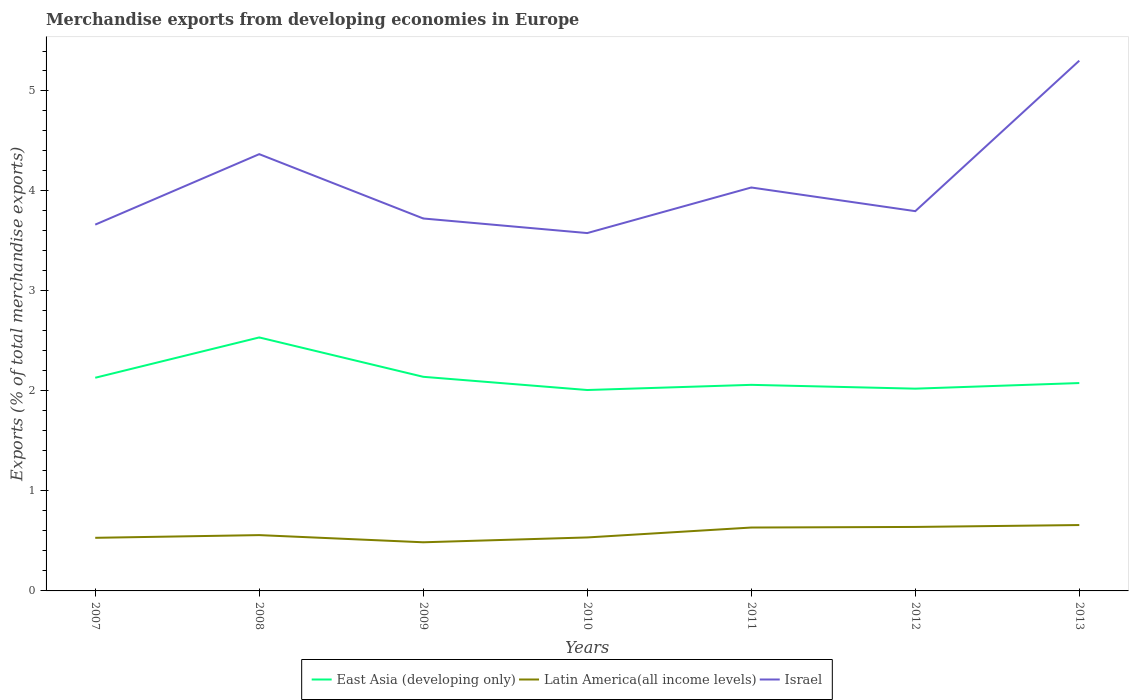Is the number of lines equal to the number of legend labels?
Provide a short and direct response. Yes. Across all years, what is the maximum percentage of total merchandise exports in Latin America(all income levels)?
Make the answer very short. 0.49. What is the total percentage of total merchandise exports in East Asia (developing only) in the graph?
Give a very brief answer. 0.53. What is the difference between the highest and the second highest percentage of total merchandise exports in East Asia (developing only)?
Offer a terse response. 0.53. What is the difference between the highest and the lowest percentage of total merchandise exports in East Asia (developing only)?
Give a very brief answer. 2. Is the percentage of total merchandise exports in East Asia (developing only) strictly greater than the percentage of total merchandise exports in Israel over the years?
Offer a terse response. Yes. What is the difference between two consecutive major ticks on the Y-axis?
Provide a succinct answer. 1. Does the graph contain any zero values?
Offer a very short reply. No. How are the legend labels stacked?
Give a very brief answer. Horizontal. What is the title of the graph?
Keep it short and to the point. Merchandise exports from developing economies in Europe. Does "Iraq" appear as one of the legend labels in the graph?
Offer a very short reply. No. What is the label or title of the Y-axis?
Offer a very short reply. Exports (% of total merchandise exports). What is the Exports (% of total merchandise exports) in East Asia (developing only) in 2007?
Offer a very short reply. 2.13. What is the Exports (% of total merchandise exports) in Latin America(all income levels) in 2007?
Keep it short and to the point. 0.53. What is the Exports (% of total merchandise exports) in Israel in 2007?
Offer a terse response. 3.66. What is the Exports (% of total merchandise exports) of East Asia (developing only) in 2008?
Offer a terse response. 2.54. What is the Exports (% of total merchandise exports) in Latin America(all income levels) in 2008?
Provide a succinct answer. 0.56. What is the Exports (% of total merchandise exports) in Israel in 2008?
Your answer should be very brief. 4.37. What is the Exports (% of total merchandise exports) in East Asia (developing only) in 2009?
Your answer should be very brief. 2.14. What is the Exports (% of total merchandise exports) in Latin America(all income levels) in 2009?
Provide a short and direct response. 0.49. What is the Exports (% of total merchandise exports) in Israel in 2009?
Your response must be concise. 3.72. What is the Exports (% of total merchandise exports) in East Asia (developing only) in 2010?
Offer a terse response. 2.01. What is the Exports (% of total merchandise exports) of Latin America(all income levels) in 2010?
Make the answer very short. 0.53. What is the Exports (% of total merchandise exports) in Israel in 2010?
Keep it short and to the point. 3.58. What is the Exports (% of total merchandise exports) of East Asia (developing only) in 2011?
Provide a succinct answer. 2.06. What is the Exports (% of total merchandise exports) of Latin America(all income levels) in 2011?
Offer a terse response. 0.63. What is the Exports (% of total merchandise exports) of Israel in 2011?
Give a very brief answer. 4.03. What is the Exports (% of total merchandise exports) of East Asia (developing only) in 2012?
Your answer should be compact. 2.02. What is the Exports (% of total merchandise exports) of Latin America(all income levels) in 2012?
Provide a succinct answer. 0.64. What is the Exports (% of total merchandise exports) of Israel in 2012?
Your answer should be compact. 3.8. What is the Exports (% of total merchandise exports) of East Asia (developing only) in 2013?
Offer a terse response. 2.08. What is the Exports (% of total merchandise exports) of Latin America(all income levels) in 2013?
Give a very brief answer. 0.66. What is the Exports (% of total merchandise exports) of Israel in 2013?
Keep it short and to the point. 5.3. Across all years, what is the maximum Exports (% of total merchandise exports) of East Asia (developing only)?
Your answer should be very brief. 2.54. Across all years, what is the maximum Exports (% of total merchandise exports) of Latin America(all income levels)?
Your answer should be very brief. 0.66. Across all years, what is the maximum Exports (% of total merchandise exports) of Israel?
Your answer should be very brief. 5.3. Across all years, what is the minimum Exports (% of total merchandise exports) in East Asia (developing only)?
Make the answer very short. 2.01. Across all years, what is the minimum Exports (% of total merchandise exports) of Latin America(all income levels)?
Provide a short and direct response. 0.49. Across all years, what is the minimum Exports (% of total merchandise exports) in Israel?
Your answer should be compact. 3.58. What is the total Exports (% of total merchandise exports) in East Asia (developing only) in the graph?
Offer a very short reply. 14.98. What is the total Exports (% of total merchandise exports) of Latin America(all income levels) in the graph?
Give a very brief answer. 4.04. What is the total Exports (% of total merchandise exports) of Israel in the graph?
Offer a terse response. 28.47. What is the difference between the Exports (% of total merchandise exports) in East Asia (developing only) in 2007 and that in 2008?
Your response must be concise. -0.4. What is the difference between the Exports (% of total merchandise exports) in Latin America(all income levels) in 2007 and that in 2008?
Offer a very short reply. -0.03. What is the difference between the Exports (% of total merchandise exports) in Israel in 2007 and that in 2008?
Make the answer very short. -0.7. What is the difference between the Exports (% of total merchandise exports) of East Asia (developing only) in 2007 and that in 2009?
Give a very brief answer. -0.01. What is the difference between the Exports (% of total merchandise exports) of Latin America(all income levels) in 2007 and that in 2009?
Give a very brief answer. 0.04. What is the difference between the Exports (% of total merchandise exports) of Israel in 2007 and that in 2009?
Offer a terse response. -0.06. What is the difference between the Exports (% of total merchandise exports) in East Asia (developing only) in 2007 and that in 2010?
Your answer should be very brief. 0.12. What is the difference between the Exports (% of total merchandise exports) of Latin America(all income levels) in 2007 and that in 2010?
Offer a very short reply. -0. What is the difference between the Exports (% of total merchandise exports) in Israel in 2007 and that in 2010?
Keep it short and to the point. 0.08. What is the difference between the Exports (% of total merchandise exports) of East Asia (developing only) in 2007 and that in 2011?
Your response must be concise. 0.07. What is the difference between the Exports (% of total merchandise exports) in Latin America(all income levels) in 2007 and that in 2011?
Your answer should be very brief. -0.1. What is the difference between the Exports (% of total merchandise exports) of Israel in 2007 and that in 2011?
Give a very brief answer. -0.37. What is the difference between the Exports (% of total merchandise exports) in East Asia (developing only) in 2007 and that in 2012?
Make the answer very short. 0.11. What is the difference between the Exports (% of total merchandise exports) in Latin America(all income levels) in 2007 and that in 2012?
Ensure brevity in your answer.  -0.11. What is the difference between the Exports (% of total merchandise exports) of Israel in 2007 and that in 2012?
Offer a very short reply. -0.13. What is the difference between the Exports (% of total merchandise exports) in East Asia (developing only) in 2007 and that in 2013?
Make the answer very short. 0.05. What is the difference between the Exports (% of total merchandise exports) in Latin America(all income levels) in 2007 and that in 2013?
Your answer should be compact. -0.13. What is the difference between the Exports (% of total merchandise exports) of Israel in 2007 and that in 2013?
Your response must be concise. -1.64. What is the difference between the Exports (% of total merchandise exports) of East Asia (developing only) in 2008 and that in 2009?
Offer a terse response. 0.39. What is the difference between the Exports (% of total merchandise exports) in Latin America(all income levels) in 2008 and that in 2009?
Provide a short and direct response. 0.07. What is the difference between the Exports (% of total merchandise exports) in Israel in 2008 and that in 2009?
Give a very brief answer. 0.64. What is the difference between the Exports (% of total merchandise exports) in East Asia (developing only) in 2008 and that in 2010?
Your answer should be very brief. 0.53. What is the difference between the Exports (% of total merchandise exports) of Latin America(all income levels) in 2008 and that in 2010?
Your answer should be very brief. 0.02. What is the difference between the Exports (% of total merchandise exports) of Israel in 2008 and that in 2010?
Ensure brevity in your answer.  0.79. What is the difference between the Exports (% of total merchandise exports) in East Asia (developing only) in 2008 and that in 2011?
Make the answer very short. 0.47. What is the difference between the Exports (% of total merchandise exports) in Latin America(all income levels) in 2008 and that in 2011?
Offer a terse response. -0.08. What is the difference between the Exports (% of total merchandise exports) of Israel in 2008 and that in 2011?
Your answer should be compact. 0.33. What is the difference between the Exports (% of total merchandise exports) of East Asia (developing only) in 2008 and that in 2012?
Keep it short and to the point. 0.51. What is the difference between the Exports (% of total merchandise exports) in Latin America(all income levels) in 2008 and that in 2012?
Offer a terse response. -0.08. What is the difference between the Exports (% of total merchandise exports) in Israel in 2008 and that in 2012?
Make the answer very short. 0.57. What is the difference between the Exports (% of total merchandise exports) of East Asia (developing only) in 2008 and that in 2013?
Your answer should be very brief. 0.46. What is the difference between the Exports (% of total merchandise exports) in Latin America(all income levels) in 2008 and that in 2013?
Your answer should be compact. -0.1. What is the difference between the Exports (% of total merchandise exports) in Israel in 2008 and that in 2013?
Keep it short and to the point. -0.94. What is the difference between the Exports (% of total merchandise exports) in East Asia (developing only) in 2009 and that in 2010?
Offer a terse response. 0.13. What is the difference between the Exports (% of total merchandise exports) of Latin America(all income levels) in 2009 and that in 2010?
Provide a succinct answer. -0.05. What is the difference between the Exports (% of total merchandise exports) in Israel in 2009 and that in 2010?
Offer a very short reply. 0.15. What is the difference between the Exports (% of total merchandise exports) of East Asia (developing only) in 2009 and that in 2011?
Provide a succinct answer. 0.08. What is the difference between the Exports (% of total merchandise exports) in Latin America(all income levels) in 2009 and that in 2011?
Your answer should be very brief. -0.15. What is the difference between the Exports (% of total merchandise exports) of Israel in 2009 and that in 2011?
Your answer should be compact. -0.31. What is the difference between the Exports (% of total merchandise exports) in East Asia (developing only) in 2009 and that in 2012?
Provide a succinct answer. 0.12. What is the difference between the Exports (% of total merchandise exports) in Latin America(all income levels) in 2009 and that in 2012?
Your response must be concise. -0.15. What is the difference between the Exports (% of total merchandise exports) in Israel in 2009 and that in 2012?
Your answer should be very brief. -0.07. What is the difference between the Exports (% of total merchandise exports) in East Asia (developing only) in 2009 and that in 2013?
Offer a terse response. 0.06. What is the difference between the Exports (% of total merchandise exports) of Latin America(all income levels) in 2009 and that in 2013?
Offer a terse response. -0.17. What is the difference between the Exports (% of total merchandise exports) of Israel in 2009 and that in 2013?
Your response must be concise. -1.58. What is the difference between the Exports (% of total merchandise exports) in East Asia (developing only) in 2010 and that in 2011?
Provide a short and direct response. -0.05. What is the difference between the Exports (% of total merchandise exports) of Latin America(all income levels) in 2010 and that in 2011?
Provide a succinct answer. -0.1. What is the difference between the Exports (% of total merchandise exports) in Israel in 2010 and that in 2011?
Your answer should be compact. -0.46. What is the difference between the Exports (% of total merchandise exports) of East Asia (developing only) in 2010 and that in 2012?
Keep it short and to the point. -0.01. What is the difference between the Exports (% of total merchandise exports) of Latin America(all income levels) in 2010 and that in 2012?
Offer a terse response. -0.1. What is the difference between the Exports (% of total merchandise exports) of Israel in 2010 and that in 2012?
Provide a short and direct response. -0.22. What is the difference between the Exports (% of total merchandise exports) in East Asia (developing only) in 2010 and that in 2013?
Provide a short and direct response. -0.07. What is the difference between the Exports (% of total merchandise exports) of Latin America(all income levels) in 2010 and that in 2013?
Offer a very short reply. -0.12. What is the difference between the Exports (% of total merchandise exports) in Israel in 2010 and that in 2013?
Your answer should be compact. -1.72. What is the difference between the Exports (% of total merchandise exports) of East Asia (developing only) in 2011 and that in 2012?
Provide a succinct answer. 0.04. What is the difference between the Exports (% of total merchandise exports) in Latin America(all income levels) in 2011 and that in 2012?
Keep it short and to the point. -0.01. What is the difference between the Exports (% of total merchandise exports) of Israel in 2011 and that in 2012?
Give a very brief answer. 0.24. What is the difference between the Exports (% of total merchandise exports) in East Asia (developing only) in 2011 and that in 2013?
Give a very brief answer. -0.02. What is the difference between the Exports (% of total merchandise exports) in Latin America(all income levels) in 2011 and that in 2013?
Offer a terse response. -0.02. What is the difference between the Exports (% of total merchandise exports) of Israel in 2011 and that in 2013?
Make the answer very short. -1.27. What is the difference between the Exports (% of total merchandise exports) in East Asia (developing only) in 2012 and that in 2013?
Ensure brevity in your answer.  -0.06. What is the difference between the Exports (% of total merchandise exports) of Latin America(all income levels) in 2012 and that in 2013?
Give a very brief answer. -0.02. What is the difference between the Exports (% of total merchandise exports) in Israel in 2012 and that in 2013?
Your answer should be very brief. -1.51. What is the difference between the Exports (% of total merchandise exports) in East Asia (developing only) in 2007 and the Exports (% of total merchandise exports) in Latin America(all income levels) in 2008?
Give a very brief answer. 1.57. What is the difference between the Exports (% of total merchandise exports) in East Asia (developing only) in 2007 and the Exports (% of total merchandise exports) in Israel in 2008?
Make the answer very short. -2.24. What is the difference between the Exports (% of total merchandise exports) of Latin America(all income levels) in 2007 and the Exports (% of total merchandise exports) of Israel in 2008?
Provide a succinct answer. -3.84. What is the difference between the Exports (% of total merchandise exports) in East Asia (developing only) in 2007 and the Exports (% of total merchandise exports) in Latin America(all income levels) in 2009?
Offer a terse response. 1.65. What is the difference between the Exports (% of total merchandise exports) of East Asia (developing only) in 2007 and the Exports (% of total merchandise exports) of Israel in 2009?
Keep it short and to the point. -1.59. What is the difference between the Exports (% of total merchandise exports) in Latin America(all income levels) in 2007 and the Exports (% of total merchandise exports) in Israel in 2009?
Keep it short and to the point. -3.19. What is the difference between the Exports (% of total merchandise exports) of East Asia (developing only) in 2007 and the Exports (% of total merchandise exports) of Latin America(all income levels) in 2010?
Provide a short and direct response. 1.6. What is the difference between the Exports (% of total merchandise exports) of East Asia (developing only) in 2007 and the Exports (% of total merchandise exports) of Israel in 2010?
Your response must be concise. -1.45. What is the difference between the Exports (% of total merchandise exports) in Latin America(all income levels) in 2007 and the Exports (% of total merchandise exports) in Israel in 2010?
Provide a succinct answer. -3.05. What is the difference between the Exports (% of total merchandise exports) of East Asia (developing only) in 2007 and the Exports (% of total merchandise exports) of Latin America(all income levels) in 2011?
Provide a succinct answer. 1.5. What is the difference between the Exports (% of total merchandise exports) in East Asia (developing only) in 2007 and the Exports (% of total merchandise exports) in Israel in 2011?
Your response must be concise. -1.9. What is the difference between the Exports (% of total merchandise exports) in Latin America(all income levels) in 2007 and the Exports (% of total merchandise exports) in Israel in 2011?
Offer a very short reply. -3.5. What is the difference between the Exports (% of total merchandise exports) of East Asia (developing only) in 2007 and the Exports (% of total merchandise exports) of Latin America(all income levels) in 2012?
Give a very brief answer. 1.49. What is the difference between the Exports (% of total merchandise exports) of East Asia (developing only) in 2007 and the Exports (% of total merchandise exports) of Israel in 2012?
Give a very brief answer. -1.67. What is the difference between the Exports (% of total merchandise exports) in Latin America(all income levels) in 2007 and the Exports (% of total merchandise exports) in Israel in 2012?
Provide a succinct answer. -3.27. What is the difference between the Exports (% of total merchandise exports) in East Asia (developing only) in 2007 and the Exports (% of total merchandise exports) in Latin America(all income levels) in 2013?
Provide a succinct answer. 1.47. What is the difference between the Exports (% of total merchandise exports) of East Asia (developing only) in 2007 and the Exports (% of total merchandise exports) of Israel in 2013?
Make the answer very short. -3.17. What is the difference between the Exports (% of total merchandise exports) of Latin America(all income levels) in 2007 and the Exports (% of total merchandise exports) of Israel in 2013?
Offer a very short reply. -4.77. What is the difference between the Exports (% of total merchandise exports) of East Asia (developing only) in 2008 and the Exports (% of total merchandise exports) of Latin America(all income levels) in 2009?
Offer a very short reply. 2.05. What is the difference between the Exports (% of total merchandise exports) of East Asia (developing only) in 2008 and the Exports (% of total merchandise exports) of Israel in 2009?
Offer a terse response. -1.19. What is the difference between the Exports (% of total merchandise exports) of Latin America(all income levels) in 2008 and the Exports (% of total merchandise exports) of Israel in 2009?
Your answer should be very brief. -3.17. What is the difference between the Exports (% of total merchandise exports) in East Asia (developing only) in 2008 and the Exports (% of total merchandise exports) in Latin America(all income levels) in 2010?
Your answer should be very brief. 2. What is the difference between the Exports (% of total merchandise exports) of East Asia (developing only) in 2008 and the Exports (% of total merchandise exports) of Israel in 2010?
Your answer should be very brief. -1.04. What is the difference between the Exports (% of total merchandise exports) of Latin America(all income levels) in 2008 and the Exports (% of total merchandise exports) of Israel in 2010?
Your response must be concise. -3.02. What is the difference between the Exports (% of total merchandise exports) of East Asia (developing only) in 2008 and the Exports (% of total merchandise exports) of Latin America(all income levels) in 2011?
Your answer should be very brief. 1.9. What is the difference between the Exports (% of total merchandise exports) of East Asia (developing only) in 2008 and the Exports (% of total merchandise exports) of Israel in 2011?
Ensure brevity in your answer.  -1.5. What is the difference between the Exports (% of total merchandise exports) of Latin America(all income levels) in 2008 and the Exports (% of total merchandise exports) of Israel in 2011?
Make the answer very short. -3.48. What is the difference between the Exports (% of total merchandise exports) in East Asia (developing only) in 2008 and the Exports (% of total merchandise exports) in Latin America(all income levels) in 2012?
Offer a terse response. 1.9. What is the difference between the Exports (% of total merchandise exports) in East Asia (developing only) in 2008 and the Exports (% of total merchandise exports) in Israel in 2012?
Provide a short and direct response. -1.26. What is the difference between the Exports (% of total merchandise exports) in Latin America(all income levels) in 2008 and the Exports (% of total merchandise exports) in Israel in 2012?
Make the answer very short. -3.24. What is the difference between the Exports (% of total merchandise exports) of East Asia (developing only) in 2008 and the Exports (% of total merchandise exports) of Latin America(all income levels) in 2013?
Offer a very short reply. 1.88. What is the difference between the Exports (% of total merchandise exports) in East Asia (developing only) in 2008 and the Exports (% of total merchandise exports) in Israel in 2013?
Keep it short and to the point. -2.77. What is the difference between the Exports (% of total merchandise exports) in Latin America(all income levels) in 2008 and the Exports (% of total merchandise exports) in Israel in 2013?
Make the answer very short. -4.75. What is the difference between the Exports (% of total merchandise exports) in East Asia (developing only) in 2009 and the Exports (% of total merchandise exports) in Latin America(all income levels) in 2010?
Provide a short and direct response. 1.61. What is the difference between the Exports (% of total merchandise exports) in East Asia (developing only) in 2009 and the Exports (% of total merchandise exports) in Israel in 2010?
Your response must be concise. -1.44. What is the difference between the Exports (% of total merchandise exports) in Latin America(all income levels) in 2009 and the Exports (% of total merchandise exports) in Israel in 2010?
Provide a succinct answer. -3.09. What is the difference between the Exports (% of total merchandise exports) in East Asia (developing only) in 2009 and the Exports (% of total merchandise exports) in Latin America(all income levels) in 2011?
Provide a short and direct response. 1.51. What is the difference between the Exports (% of total merchandise exports) in East Asia (developing only) in 2009 and the Exports (% of total merchandise exports) in Israel in 2011?
Your answer should be very brief. -1.89. What is the difference between the Exports (% of total merchandise exports) of Latin America(all income levels) in 2009 and the Exports (% of total merchandise exports) of Israel in 2011?
Keep it short and to the point. -3.55. What is the difference between the Exports (% of total merchandise exports) of East Asia (developing only) in 2009 and the Exports (% of total merchandise exports) of Latin America(all income levels) in 2012?
Provide a short and direct response. 1.5. What is the difference between the Exports (% of total merchandise exports) in East Asia (developing only) in 2009 and the Exports (% of total merchandise exports) in Israel in 2012?
Make the answer very short. -1.66. What is the difference between the Exports (% of total merchandise exports) in Latin America(all income levels) in 2009 and the Exports (% of total merchandise exports) in Israel in 2012?
Provide a succinct answer. -3.31. What is the difference between the Exports (% of total merchandise exports) of East Asia (developing only) in 2009 and the Exports (% of total merchandise exports) of Latin America(all income levels) in 2013?
Ensure brevity in your answer.  1.48. What is the difference between the Exports (% of total merchandise exports) in East Asia (developing only) in 2009 and the Exports (% of total merchandise exports) in Israel in 2013?
Ensure brevity in your answer.  -3.16. What is the difference between the Exports (% of total merchandise exports) in Latin America(all income levels) in 2009 and the Exports (% of total merchandise exports) in Israel in 2013?
Provide a short and direct response. -4.82. What is the difference between the Exports (% of total merchandise exports) in East Asia (developing only) in 2010 and the Exports (% of total merchandise exports) in Latin America(all income levels) in 2011?
Ensure brevity in your answer.  1.38. What is the difference between the Exports (% of total merchandise exports) in East Asia (developing only) in 2010 and the Exports (% of total merchandise exports) in Israel in 2011?
Offer a terse response. -2.03. What is the difference between the Exports (% of total merchandise exports) in Latin America(all income levels) in 2010 and the Exports (% of total merchandise exports) in Israel in 2011?
Make the answer very short. -3.5. What is the difference between the Exports (% of total merchandise exports) in East Asia (developing only) in 2010 and the Exports (% of total merchandise exports) in Latin America(all income levels) in 2012?
Your answer should be compact. 1.37. What is the difference between the Exports (% of total merchandise exports) in East Asia (developing only) in 2010 and the Exports (% of total merchandise exports) in Israel in 2012?
Provide a succinct answer. -1.79. What is the difference between the Exports (% of total merchandise exports) in Latin America(all income levels) in 2010 and the Exports (% of total merchandise exports) in Israel in 2012?
Make the answer very short. -3.26. What is the difference between the Exports (% of total merchandise exports) in East Asia (developing only) in 2010 and the Exports (% of total merchandise exports) in Latin America(all income levels) in 2013?
Your response must be concise. 1.35. What is the difference between the Exports (% of total merchandise exports) in East Asia (developing only) in 2010 and the Exports (% of total merchandise exports) in Israel in 2013?
Provide a succinct answer. -3.29. What is the difference between the Exports (% of total merchandise exports) in Latin America(all income levels) in 2010 and the Exports (% of total merchandise exports) in Israel in 2013?
Provide a succinct answer. -4.77. What is the difference between the Exports (% of total merchandise exports) in East Asia (developing only) in 2011 and the Exports (% of total merchandise exports) in Latin America(all income levels) in 2012?
Your response must be concise. 1.42. What is the difference between the Exports (% of total merchandise exports) of East Asia (developing only) in 2011 and the Exports (% of total merchandise exports) of Israel in 2012?
Provide a short and direct response. -1.74. What is the difference between the Exports (% of total merchandise exports) of Latin America(all income levels) in 2011 and the Exports (% of total merchandise exports) of Israel in 2012?
Keep it short and to the point. -3.16. What is the difference between the Exports (% of total merchandise exports) in East Asia (developing only) in 2011 and the Exports (% of total merchandise exports) in Latin America(all income levels) in 2013?
Provide a short and direct response. 1.4. What is the difference between the Exports (% of total merchandise exports) in East Asia (developing only) in 2011 and the Exports (% of total merchandise exports) in Israel in 2013?
Ensure brevity in your answer.  -3.24. What is the difference between the Exports (% of total merchandise exports) in Latin America(all income levels) in 2011 and the Exports (% of total merchandise exports) in Israel in 2013?
Give a very brief answer. -4.67. What is the difference between the Exports (% of total merchandise exports) in East Asia (developing only) in 2012 and the Exports (% of total merchandise exports) in Latin America(all income levels) in 2013?
Your answer should be compact. 1.36. What is the difference between the Exports (% of total merchandise exports) in East Asia (developing only) in 2012 and the Exports (% of total merchandise exports) in Israel in 2013?
Your response must be concise. -3.28. What is the difference between the Exports (% of total merchandise exports) in Latin America(all income levels) in 2012 and the Exports (% of total merchandise exports) in Israel in 2013?
Give a very brief answer. -4.66. What is the average Exports (% of total merchandise exports) in East Asia (developing only) per year?
Keep it short and to the point. 2.14. What is the average Exports (% of total merchandise exports) of Latin America(all income levels) per year?
Give a very brief answer. 0.58. What is the average Exports (% of total merchandise exports) of Israel per year?
Offer a very short reply. 4.07. In the year 2007, what is the difference between the Exports (% of total merchandise exports) in East Asia (developing only) and Exports (% of total merchandise exports) in Latin America(all income levels)?
Offer a very short reply. 1.6. In the year 2007, what is the difference between the Exports (% of total merchandise exports) of East Asia (developing only) and Exports (% of total merchandise exports) of Israel?
Make the answer very short. -1.53. In the year 2007, what is the difference between the Exports (% of total merchandise exports) of Latin America(all income levels) and Exports (% of total merchandise exports) of Israel?
Make the answer very short. -3.13. In the year 2008, what is the difference between the Exports (% of total merchandise exports) in East Asia (developing only) and Exports (% of total merchandise exports) in Latin America(all income levels)?
Your response must be concise. 1.98. In the year 2008, what is the difference between the Exports (% of total merchandise exports) in East Asia (developing only) and Exports (% of total merchandise exports) in Israel?
Your answer should be very brief. -1.83. In the year 2008, what is the difference between the Exports (% of total merchandise exports) in Latin America(all income levels) and Exports (% of total merchandise exports) in Israel?
Offer a terse response. -3.81. In the year 2009, what is the difference between the Exports (% of total merchandise exports) of East Asia (developing only) and Exports (% of total merchandise exports) of Latin America(all income levels)?
Keep it short and to the point. 1.66. In the year 2009, what is the difference between the Exports (% of total merchandise exports) of East Asia (developing only) and Exports (% of total merchandise exports) of Israel?
Ensure brevity in your answer.  -1.58. In the year 2009, what is the difference between the Exports (% of total merchandise exports) of Latin America(all income levels) and Exports (% of total merchandise exports) of Israel?
Make the answer very short. -3.24. In the year 2010, what is the difference between the Exports (% of total merchandise exports) of East Asia (developing only) and Exports (% of total merchandise exports) of Latin America(all income levels)?
Your answer should be compact. 1.47. In the year 2010, what is the difference between the Exports (% of total merchandise exports) in East Asia (developing only) and Exports (% of total merchandise exports) in Israel?
Offer a very short reply. -1.57. In the year 2010, what is the difference between the Exports (% of total merchandise exports) of Latin America(all income levels) and Exports (% of total merchandise exports) of Israel?
Offer a terse response. -3.04. In the year 2011, what is the difference between the Exports (% of total merchandise exports) of East Asia (developing only) and Exports (% of total merchandise exports) of Latin America(all income levels)?
Offer a terse response. 1.43. In the year 2011, what is the difference between the Exports (% of total merchandise exports) in East Asia (developing only) and Exports (% of total merchandise exports) in Israel?
Offer a terse response. -1.97. In the year 2011, what is the difference between the Exports (% of total merchandise exports) in Latin America(all income levels) and Exports (% of total merchandise exports) in Israel?
Your answer should be compact. -3.4. In the year 2012, what is the difference between the Exports (% of total merchandise exports) of East Asia (developing only) and Exports (% of total merchandise exports) of Latin America(all income levels)?
Offer a terse response. 1.38. In the year 2012, what is the difference between the Exports (% of total merchandise exports) of East Asia (developing only) and Exports (% of total merchandise exports) of Israel?
Make the answer very short. -1.78. In the year 2012, what is the difference between the Exports (% of total merchandise exports) in Latin America(all income levels) and Exports (% of total merchandise exports) in Israel?
Make the answer very short. -3.16. In the year 2013, what is the difference between the Exports (% of total merchandise exports) in East Asia (developing only) and Exports (% of total merchandise exports) in Latin America(all income levels)?
Your response must be concise. 1.42. In the year 2013, what is the difference between the Exports (% of total merchandise exports) of East Asia (developing only) and Exports (% of total merchandise exports) of Israel?
Provide a short and direct response. -3.22. In the year 2013, what is the difference between the Exports (% of total merchandise exports) of Latin America(all income levels) and Exports (% of total merchandise exports) of Israel?
Make the answer very short. -4.64. What is the ratio of the Exports (% of total merchandise exports) in East Asia (developing only) in 2007 to that in 2008?
Give a very brief answer. 0.84. What is the ratio of the Exports (% of total merchandise exports) of Latin America(all income levels) in 2007 to that in 2008?
Make the answer very short. 0.95. What is the ratio of the Exports (% of total merchandise exports) of Israel in 2007 to that in 2008?
Provide a short and direct response. 0.84. What is the ratio of the Exports (% of total merchandise exports) of Latin America(all income levels) in 2007 to that in 2009?
Offer a terse response. 1.09. What is the ratio of the Exports (% of total merchandise exports) of Israel in 2007 to that in 2009?
Provide a short and direct response. 0.98. What is the ratio of the Exports (% of total merchandise exports) of East Asia (developing only) in 2007 to that in 2010?
Ensure brevity in your answer.  1.06. What is the ratio of the Exports (% of total merchandise exports) in Israel in 2007 to that in 2010?
Your answer should be compact. 1.02. What is the ratio of the Exports (% of total merchandise exports) in East Asia (developing only) in 2007 to that in 2011?
Your answer should be very brief. 1.03. What is the ratio of the Exports (% of total merchandise exports) in Latin America(all income levels) in 2007 to that in 2011?
Your answer should be very brief. 0.84. What is the ratio of the Exports (% of total merchandise exports) of Israel in 2007 to that in 2011?
Your answer should be very brief. 0.91. What is the ratio of the Exports (% of total merchandise exports) of East Asia (developing only) in 2007 to that in 2012?
Your answer should be very brief. 1.05. What is the ratio of the Exports (% of total merchandise exports) of Latin America(all income levels) in 2007 to that in 2012?
Your response must be concise. 0.83. What is the ratio of the Exports (% of total merchandise exports) in Israel in 2007 to that in 2012?
Ensure brevity in your answer.  0.96. What is the ratio of the Exports (% of total merchandise exports) in East Asia (developing only) in 2007 to that in 2013?
Offer a very short reply. 1.03. What is the ratio of the Exports (% of total merchandise exports) in Latin America(all income levels) in 2007 to that in 2013?
Your answer should be compact. 0.81. What is the ratio of the Exports (% of total merchandise exports) in Israel in 2007 to that in 2013?
Make the answer very short. 0.69. What is the ratio of the Exports (% of total merchandise exports) of East Asia (developing only) in 2008 to that in 2009?
Provide a succinct answer. 1.18. What is the ratio of the Exports (% of total merchandise exports) of Latin America(all income levels) in 2008 to that in 2009?
Offer a terse response. 1.15. What is the ratio of the Exports (% of total merchandise exports) of Israel in 2008 to that in 2009?
Give a very brief answer. 1.17. What is the ratio of the Exports (% of total merchandise exports) in East Asia (developing only) in 2008 to that in 2010?
Provide a short and direct response. 1.26. What is the ratio of the Exports (% of total merchandise exports) in Latin America(all income levels) in 2008 to that in 2010?
Offer a very short reply. 1.04. What is the ratio of the Exports (% of total merchandise exports) in Israel in 2008 to that in 2010?
Give a very brief answer. 1.22. What is the ratio of the Exports (% of total merchandise exports) of East Asia (developing only) in 2008 to that in 2011?
Ensure brevity in your answer.  1.23. What is the ratio of the Exports (% of total merchandise exports) of Latin America(all income levels) in 2008 to that in 2011?
Ensure brevity in your answer.  0.88. What is the ratio of the Exports (% of total merchandise exports) in Israel in 2008 to that in 2011?
Give a very brief answer. 1.08. What is the ratio of the Exports (% of total merchandise exports) of East Asia (developing only) in 2008 to that in 2012?
Your answer should be very brief. 1.25. What is the ratio of the Exports (% of total merchandise exports) in Latin America(all income levels) in 2008 to that in 2012?
Offer a terse response. 0.87. What is the ratio of the Exports (% of total merchandise exports) of Israel in 2008 to that in 2012?
Your response must be concise. 1.15. What is the ratio of the Exports (% of total merchandise exports) of East Asia (developing only) in 2008 to that in 2013?
Make the answer very short. 1.22. What is the ratio of the Exports (% of total merchandise exports) in Latin America(all income levels) in 2008 to that in 2013?
Ensure brevity in your answer.  0.85. What is the ratio of the Exports (% of total merchandise exports) in Israel in 2008 to that in 2013?
Your answer should be compact. 0.82. What is the ratio of the Exports (% of total merchandise exports) in East Asia (developing only) in 2009 to that in 2010?
Provide a succinct answer. 1.07. What is the ratio of the Exports (% of total merchandise exports) in Latin America(all income levels) in 2009 to that in 2010?
Offer a very short reply. 0.91. What is the ratio of the Exports (% of total merchandise exports) in Israel in 2009 to that in 2010?
Your answer should be very brief. 1.04. What is the ratio of the Exports (% of total merchandise exports) of East Asia (developing only) in 2009 to that in 2011?
Your answer should be compact. 1.04. What is the ratio of the Exports (% of total merchandise exports) of Latin America(all income levels) in 2009 to that in 2011?
Your answer should be very brief. 0.77. What is the ratio of the Exports (% of total merchandise exports) of Israel in 2009 to that in 2011?
Ensure brevity in your answer.  0.92. What is the ratio of the Exports (% of total merchandise exports) in East Asia (developing only) in 2009 to that in 2012?
Offer a terse response. 1.06. What is the ratio of the Exports (% of total merchandise exports) in Latin America(all income levels) in 2009 to that in 2012?
Give a very brief answer. 0.76. What is the ratio of the Exports (% of total merchandise exports) in Israel in 2009 to that in 2012?
Offer a terse response. 0.98. What is the ratio of the Exports (% of total merchandise exports) in Latin America(all income levels) in 2009 to that in 2013?
Make the answer very short. 0.74. What is the ratio of the Exports (% of total merchandise exports) in Israel in 2009 to that in 2013?
Make the answer very short. 0.7. What is the ratio of the Exports (% of total merchandise exports) in East Asia (developing only) in 2010 to that in 2011?
Give a very brief answer. 0.97. What is the ratio of the Exports (% of total merchandise exports) of Latin America(all income levels) in 2010 to that in 2011?
Your answer should be compact. 0.84. What is the ratio of the Exports (% of total merchandise exports) of Israel in 2010 to that in 2011?
Keep it short and to the point. 0.89. What is the ratio of the Exports (% of total merchandise exports) in East Asia (developing only) in 2010 to that in 2012?
Your answer should be very brief. 0.99. What is the ratio of the Exports (% of total merchandise exports) in Latin America(all income levels) in 2010 to that in 2012?
Offer a very short reply. 0.84. What is the ratio of the Exports (% of total merchandise exports) of Israel in 2010 to that in 2012?
Your answer should be compact. 0.94. What is the ratio of the Exports (% of total merchandise exports) in East Asia (developing only) in 2010 to that in 2013?
Offer a terse response. 0.97. What is the ratio of the Exports (% of total merchandise exports) of Latin America(all income levels) in 2010 to that in 2013?
Provide a succinct answer. 0.81. What is the ratio of the Exports (% of total merchandise exports) in Israel in 2010 to that in 2013?
Your answer should be compact. 0.67. What is the ratio of the Exports (% of total merchandise exports) in East Asia (developing only) in 2011 to that in 2012?
Provide a short and direct response. 1.02. What is the ratio of the Exports (% of total merchandise exports) in Latin America(all income levels) in 2011 to that in 2012?
Your response must be concise. 0.99. What is the ratio of the Exports (% of total merchandise exports) in Israel in 2011 to that in 2012?
Provide a succinct answer. 1.06. What is the ratio of the Exports (% of total merchandise exports) of Latin America(all income levels) in 2011 to that in 2013?
Your answer should be compact. 0.96. What is the ratio of the Exports (% of total merchandise exports) of Israel in 2011 to that in 2013?
Offer a terse response. 0.76. What is the ratio of the Exports (% of total merchandise exports) of Latin America(all income levels) in 2012 to that in 2013?
Your answer should be very brief. 0.97. What is the ratio of the Exports (% of total merchandise exports) in Israel in 2012 to that in 2013?
Make the answer very short. 0.72. What is the difference between the highest and the second highest Exports (% of total merchandise exports) of East Asia (developing only)?
Make the answer very short. 0.39. What is the difference between the highest and the second highest Exports (% of total merchandise exports) of Latin America(all income levels)?
Your answer should be compact. 0.02. What is the difference between the highest and the second highest Exports (% of total merchandise exports) of Israel?
Keep it short and to the point. 0.94. What is the difference between the highest and the lowest Exports (% of total merchandise exports) of East Asia (developing only)?
Your answer should be compact. 0.53. What is the difference between the highest and the lowest Exports (% of total merchandise exports) in Latin America(all income levels)?
Keep it short and to the point. 0.17. What is the difference between the highest and the lowest Exports (% of total merchandise exports) in Israel?
Give a very brief answer. 1.72. 